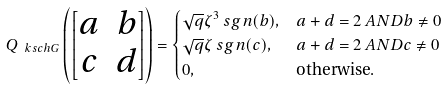Convert formula to latex. <formula><loc_0><loc_0><loc_500><loc_500>Q _ { \ k s c h { G } } \left ( \begin{bmatrix} a & b \\ c & d \end{bmatrix} \right ) & = \begin{cases} \sqrt { q } \zeta ^ { 3 } { \ s g n } ( b ) , & a + d = 2 \ A N D b \ne 0 \\ \sqrt { q } \zeta { \ s g n } ( c ) , & a + d = 2 \ A N D c \ne 0 \\ 0 , & \text {otherwise} . \end{cases}</formula> 